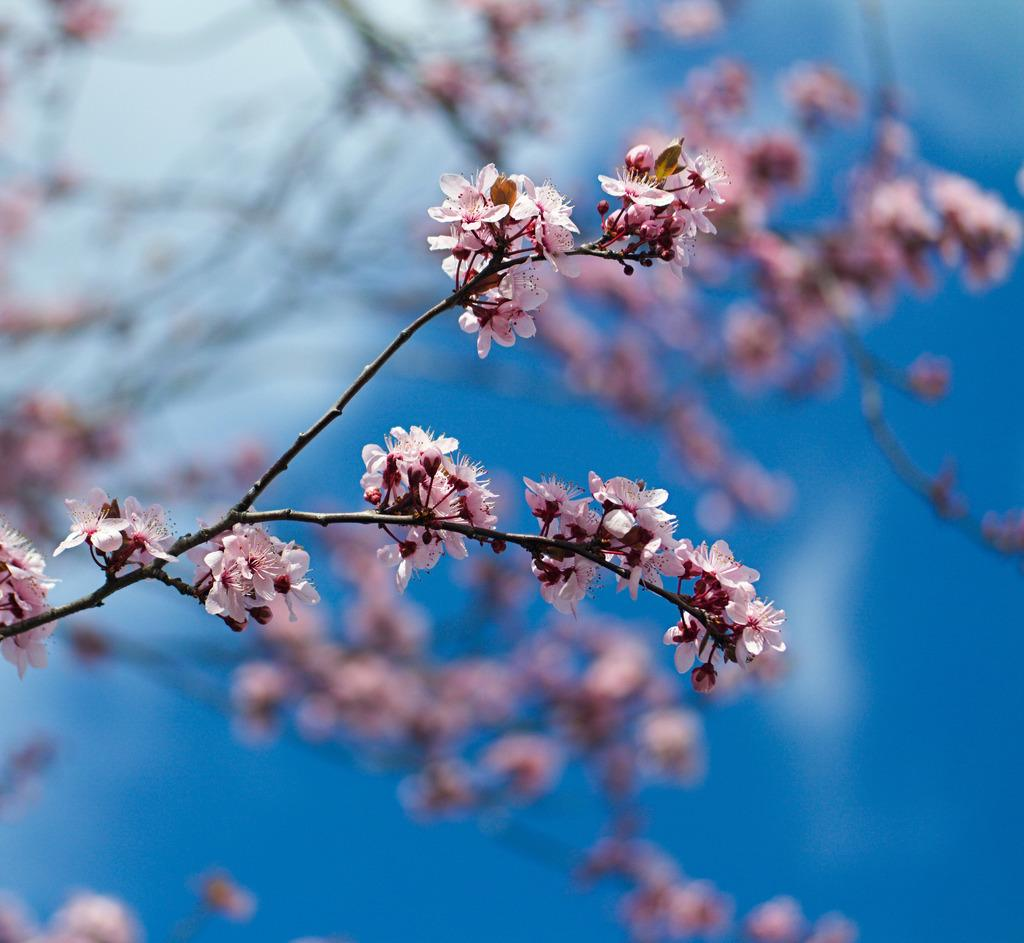What colors of flowers can be seen in the image? There are white and peach color flowers in the image. Where are the flowers located? The flowers are on a plant. What color is the background in the image? The background in the image is blue. What scientific theory can be observed in the image? There is no scientific theory present in the image; it features flowers on a plant with a blue background. What type of fruit is visible in the image? There is no fruit present in the image; it features flowers on a plant with a blue background. 